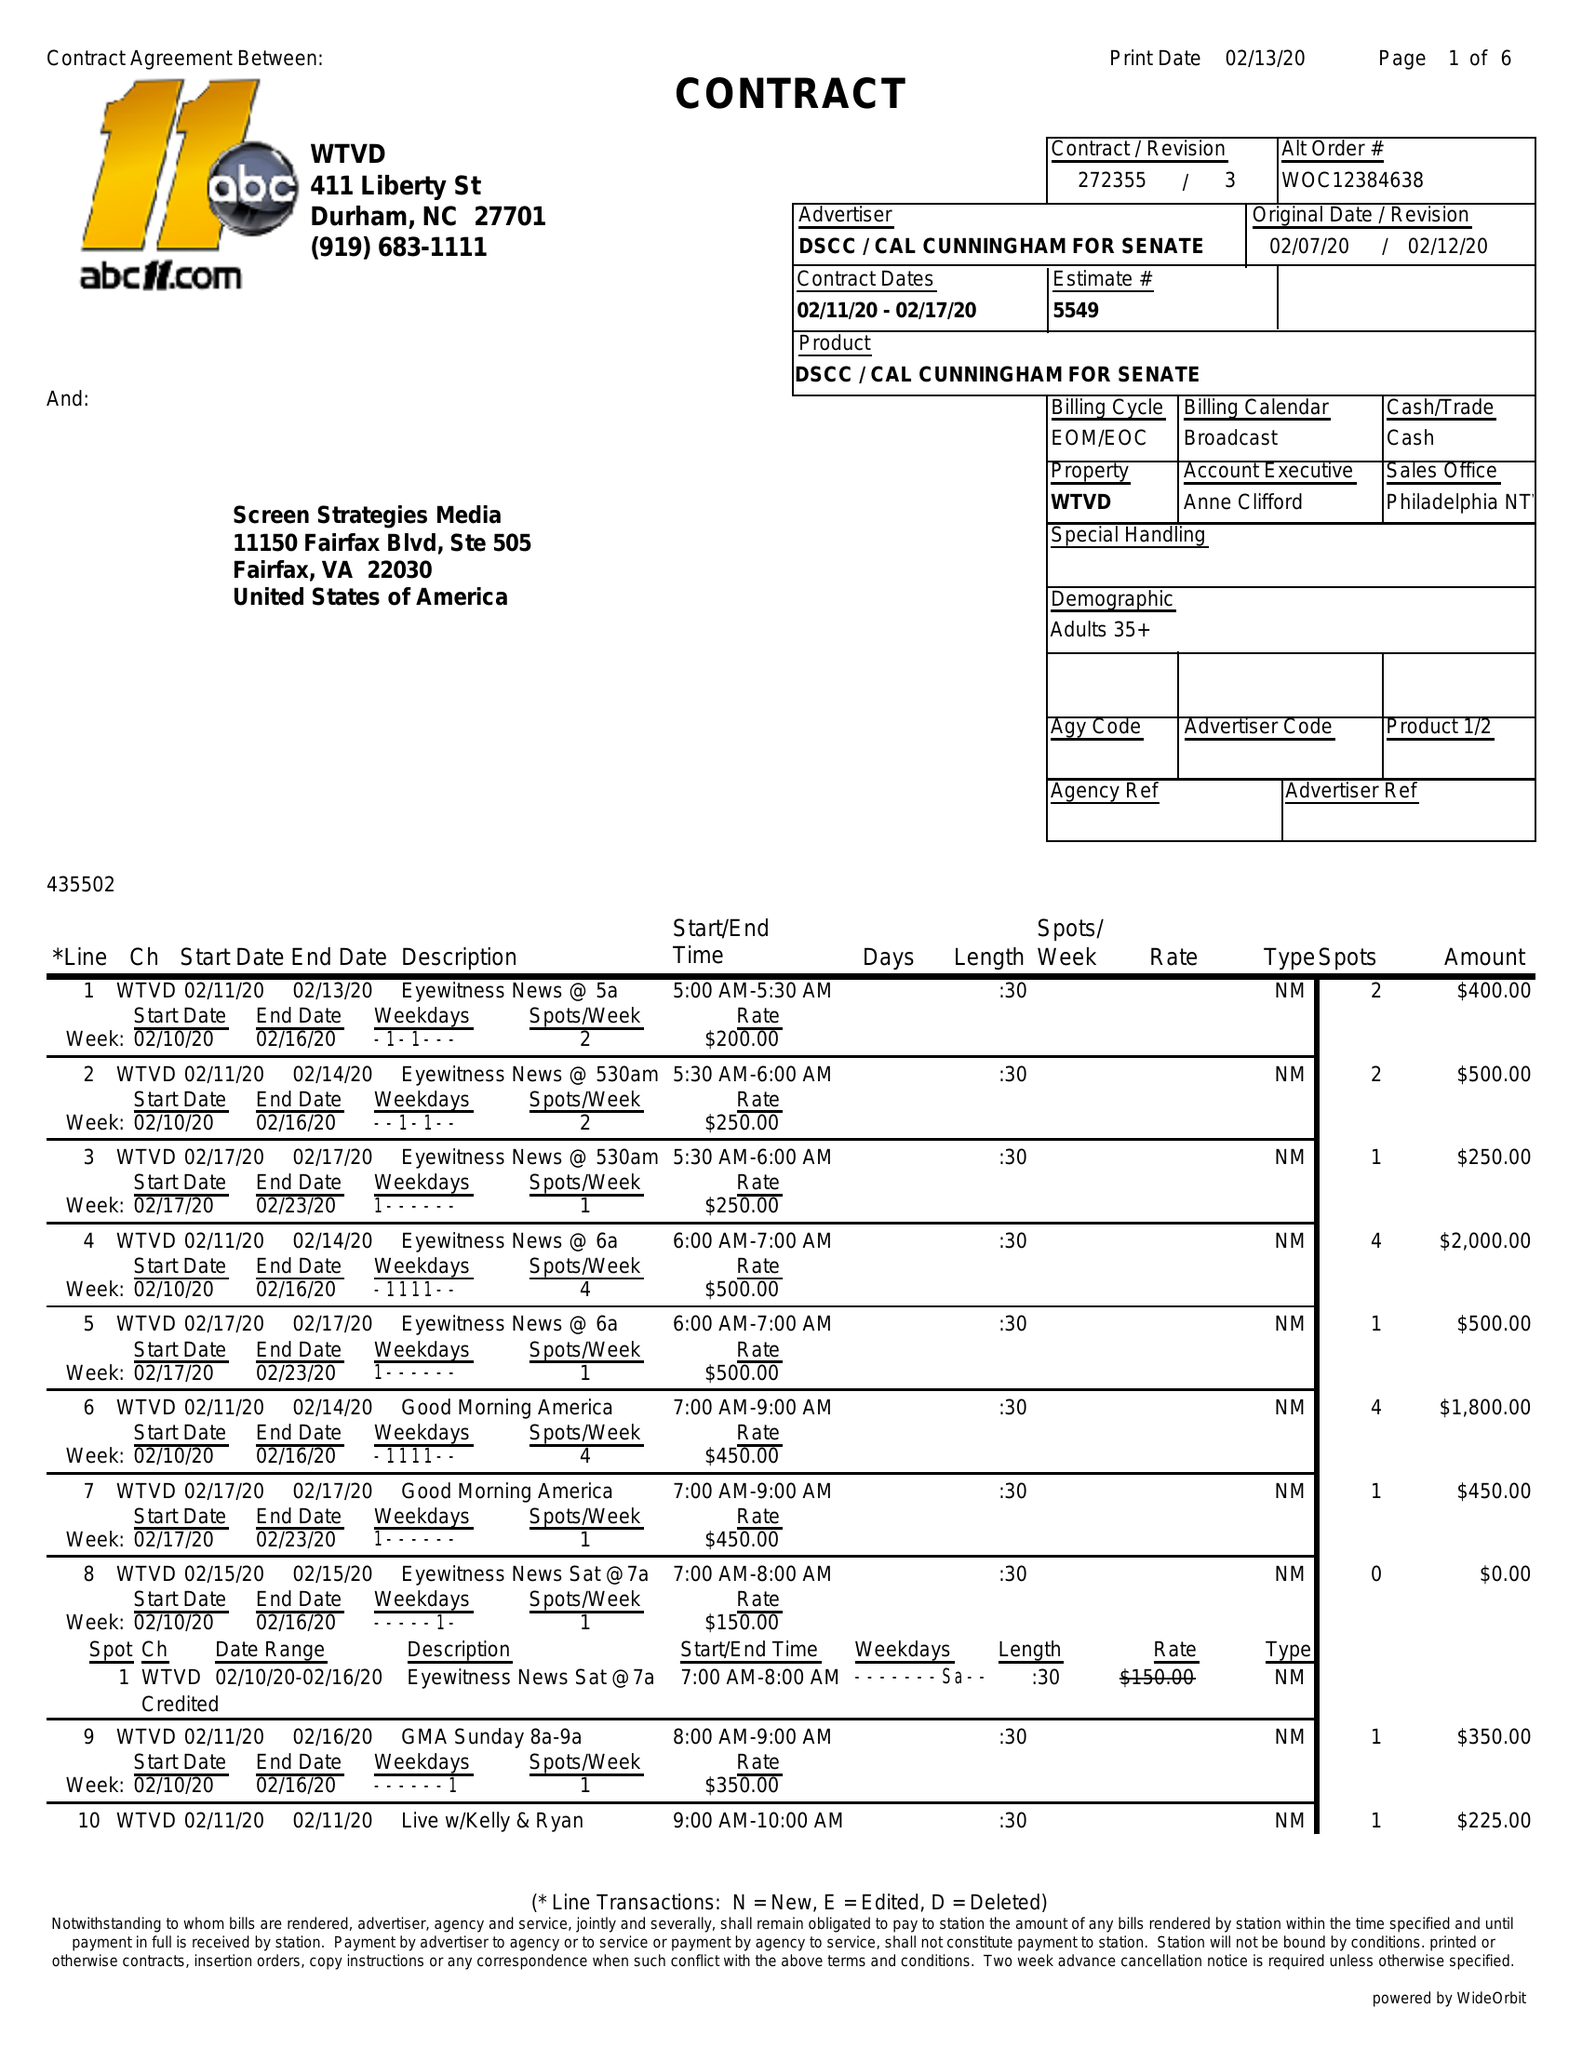What is the value for the flight_to?
Answer the question using a single word or phrase. 02/17/20 